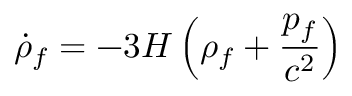<formula> <loc_0><loc_0><loc_500><loc_500>{ \dot { \rho } } _ { f } = - 3 H \left ( \rho _ { f } + { \frac { p _ { f } } { c ^ { 2 } } } \right )</formula> 